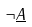<formula> <loc_0><loc_0><loc_500><loc_500>\neg \underline { A }</formula> 